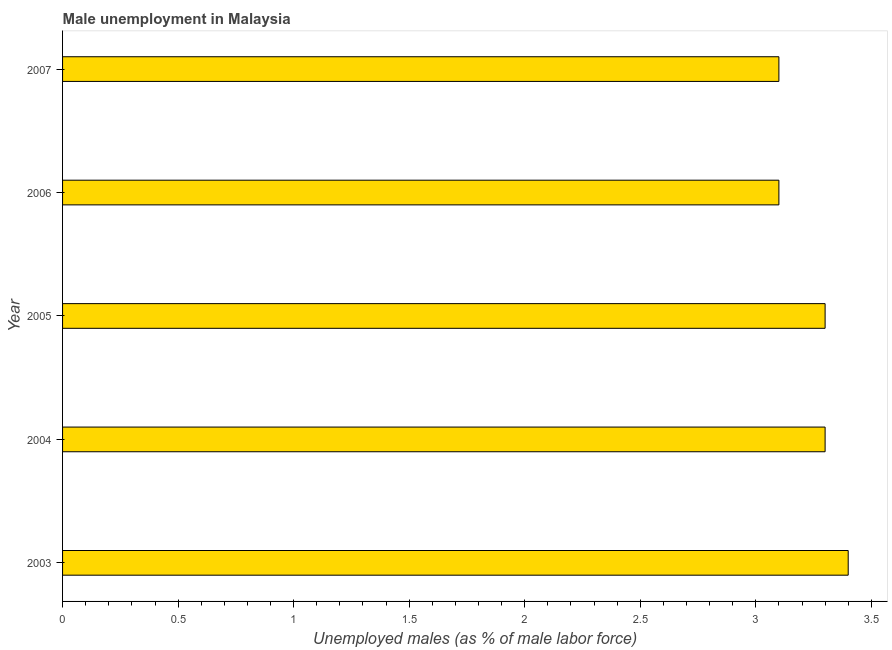Does the graph contain grids?
Ensure brevity in your answer.  No. What is the title of the graph?
Your answer should be very brief. Male unemployment in Malaysia. What is the label or title of the X-axis?
Provide a succinct answer. Unemployed males (as % of male labor force). What is the label or title of the Y-axis?
Make the answer very short. Year. What is the unemployed males population in 2005?
Your answer should be compact. 3.3. Across all years, what is the maximum unemployed males population?
Provide a succinct answer. 3.4. Across all years, what is the minimum unemployed males population?
Keep it short and to the point. 3.1. In which year was the unemployed males population minimum?
Ensure brevity in your answer.  2006. What is the sum of the unemployed males population?
Give a very brief answer. 16.2. What is the difference between the unemployed males population in 2004 and 2007?
Provide a short and direct response. 0.2. What is the average unemployed males population per year?
Ensure brevity in your answer.  3.24. What is the median unemployed males population?
Your answer should be very brief. 3.3. What is the ratio of the unemployed males population in 2005 to that in 2006?
Ensure brevity in your answer.  1.06. Is the difference between the unemployed males population in 2005 and 2006 greater than the difference between any two years?
Keep it short and to the point. No. What is the difference between the highest and the second highest unemployed males population?
Offer a terse response. 0.1. Are the values on the major ticks of X-axis written in scientific E-notation?
Your answer should be compact. No. What is the Unemployed males (as % of male labor force) of 2003?
Ensure brevity in your answer.  3.4. What is the Unemployed males (as % of male labor force) in 2004?
Offer a very short reply. 3.3. What is the Unemployed males (as % of male labor force) in 2005?
Ensure brevity in your answer.  3.3. What is the Unemployed males (as % of male labor force) of 2006?
Provide a short and direct response. 3.1. What is the Unemployed males (as % of male labor force) of 2007?
Your answer should be compact. 3.1. What is the difference between the Unemployed males (as % of male labor force) in 2003 and 2004?
Your answer should be compact. 0.1. What is the difference between the Unemployed males (as % of male labor force) in 2003 and 2005?
Make the answer very short. 0.1. What is the difference between the Unemployed males (as % of male labor force) in 2003 and 2007?
Your answer should be very brief. 0.3. What is the difference between the Unemployed males (as % of male labor force) in 2004 and 2006?
Keep it short and to the point. 0.2. What is the difference between the Unemployed males (as % of male labor force) in 2004 and 2007?
Give a very brief answer. 0.2. What is the difference between the Unemployed males (as % of male labor force) in 2005 and 2006?
Give a very brief answer. 0.2. What is the difference between the Unemployed males (as % of male labor force) in 2005 and 2007?
Your answer should be compact. 0.2. What is the difference between the Unemployed males (as % of male labor force) in 2006 and 2007?
Keep it short and to the point. 0. What is the ratio of the Unemployed males (as % of male labor force) in 2003 to that in 2004?
Your answer should be very brief. 1.03. What is the ratio of the Unemployed males (as % of male labor force) in 2003 to that in 2005?
Provide a succinct answer. 1.03. What is the ratio of the Unemployed males (as % of male labor force) in 2003 to that in 2006?
Your answer should be very brief. 1.1. What is the ratio of the Unemployed males (as % of male labor force) in 2003 to that in 2007?
Your answer should be very brief. 1.1. What is the ratio of the Unemployed males (as % of male labor force) in 2004 to that in 2005?
Provide a succinct answer. 1. What is the ratio of the Unemployed males (as % of male labor force) in 2004 to that in 2006?
Your answer should be very brief. 1.06. What is the ratio of the Unemployed males (as % of male labor force) in 2004 to that in 2007?
Keep it short and to the point. 1.06. What is the ratio of the Unemployed males (as % of male labor force) in 2005 to that in 2006?
Offer a terse response. 1.06. What is the ratio of the Unemployed males (as % of male labor force) in 2005 to that in 2007?
Ensure brevity in your answer.  1.06. 